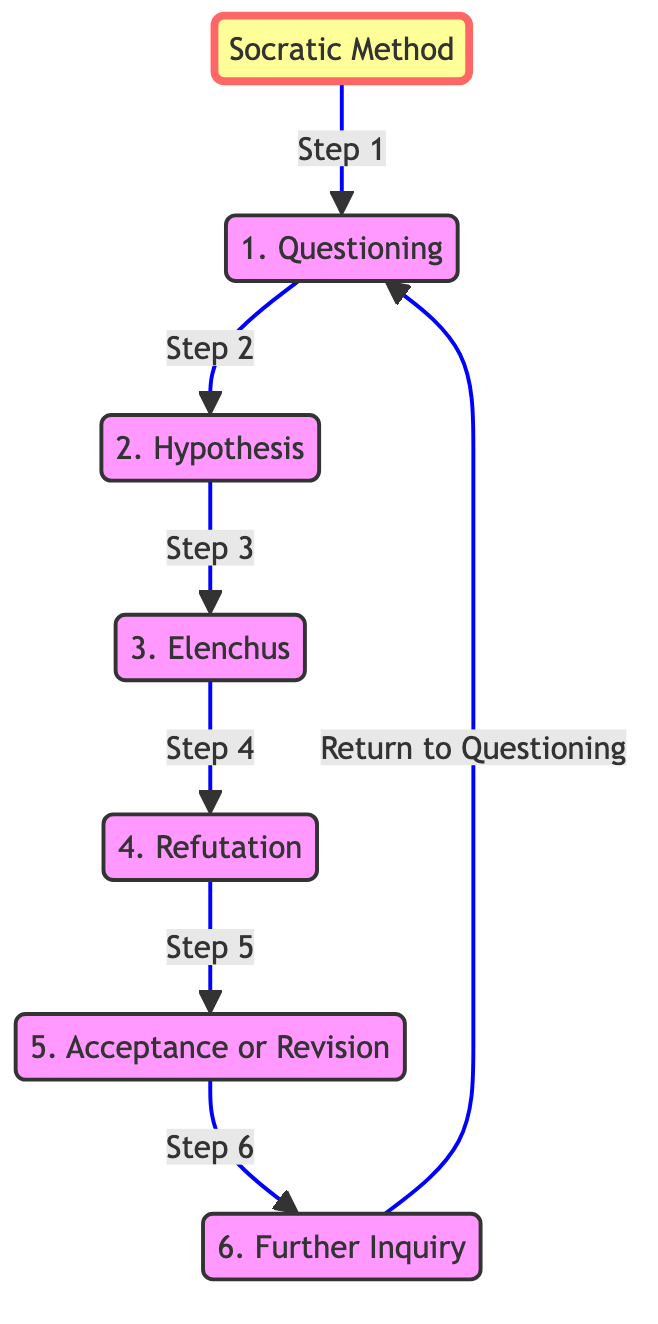What is the first step in the Socratic Method? According to the diagram, the first step is directly labeled as "1. Questioning".
Answer: Questioning How many steps are there in the Socratic Method as represented in the diagram? The diagram contains six steps, numbered from 1 to 6.
Answer: 6 What follows "Elenchus" in the sequence? From the diagram, "Elenchus" is followed by "4. Refutation", as indicated by the arrow connecting the two nodes.
Answer: Refutation What does the last step lead back to? The last step, "6. Further Inquiry", leads back to "1. Questioning", as shown by the arrow returning to the first node.
Answer: Questioning What connects "Hypothesis" to "Elenchus"? The connection between "Hypothesis" and "Elenchus" is a directed edge labeled as "Step 3", indicating the sequential flow from one to the other.
Answer: Step 3 